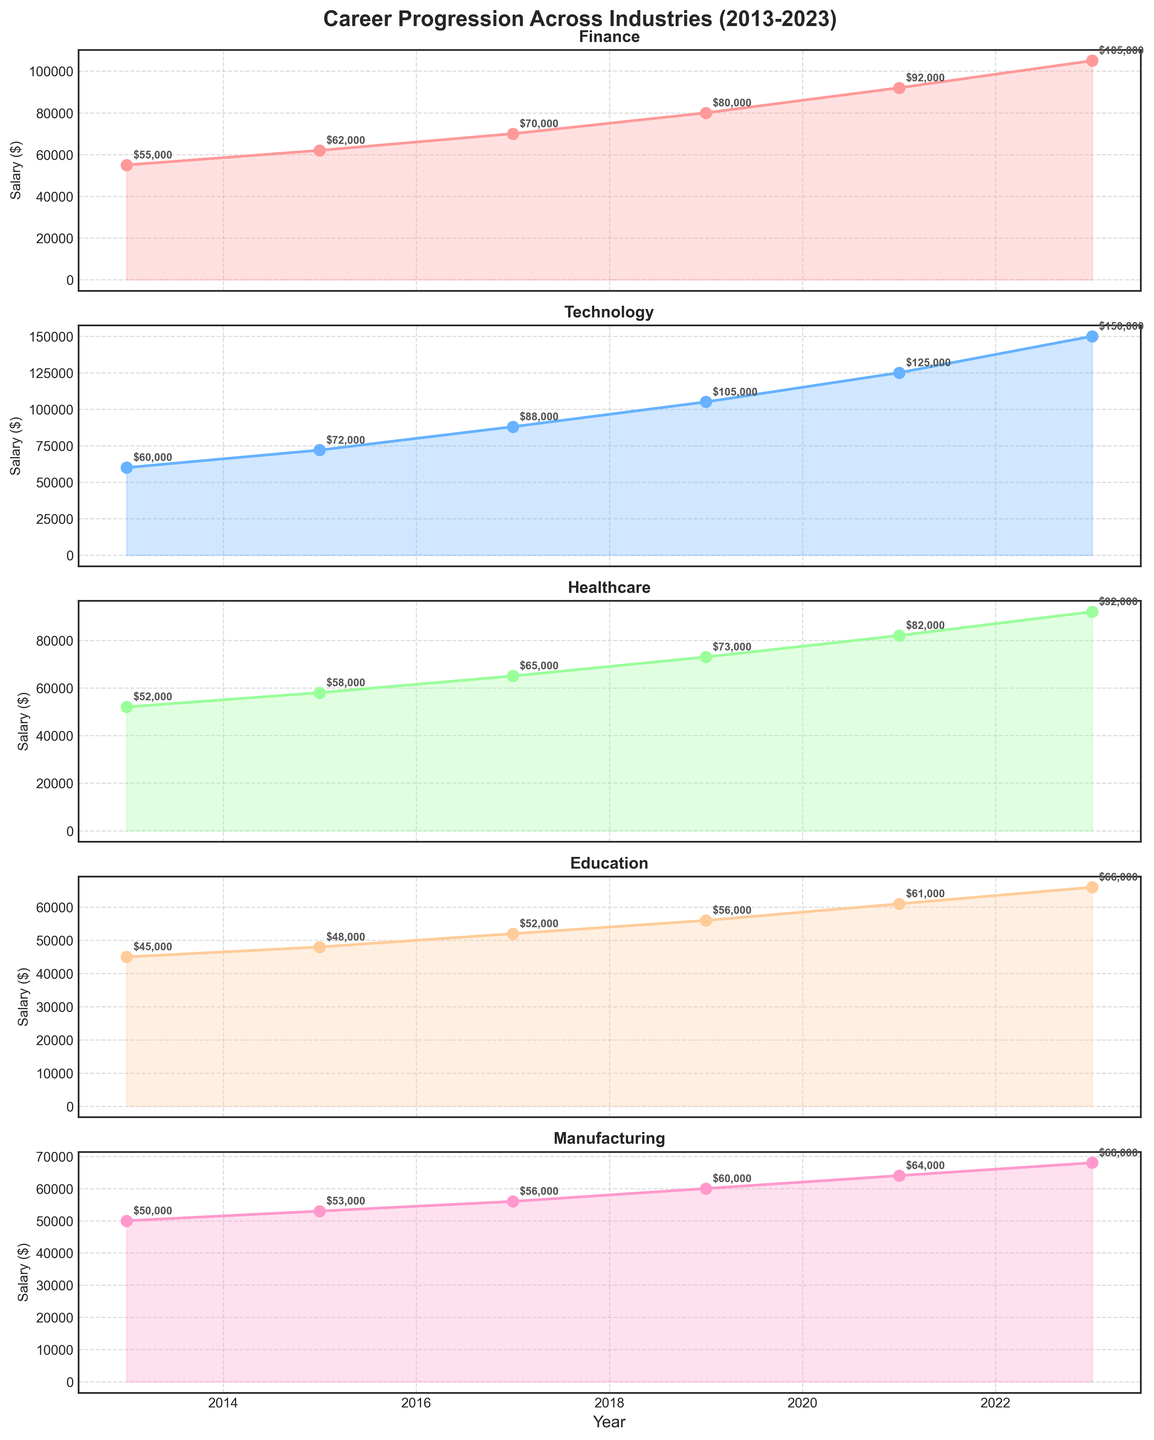What is the title of the figure? The title is located at the top center of the figure and reads "Career Progression Across Industries (2013-2023)"
Answer: Career Progression Across Industries (2013-2023) Which industry had the highest salary in 2023? Look at the salary data for all industries in 2023, and compare them visually. The Technology industry stands out with the highest salary.
Answer: Technology How much did the manufacturing industry salary increase from 2013 to 2023? Extract the salary data for the Manufacturing industry in 2013 and 2023. Subtract the 2013 value from the 2023 value: 68,000 - 50,000 = 18,000
Answer: 18,000 Which industry experienced the most rapid salary growth between 2013 and 2023? Calculate the salary difference between 2023 and 2013 for each industry. Compare those values to determine the highest: Technology (150,000 - 60,000 = 90,000).
Answer: Technology What was the average salary in the Healthcare industry over the 10-year period? Add the salaries for the Healthcare industry from 2013, 2015, 2017, 2019, 2021, and 2023 and divide by the number of years: (52,000 + 58,000 + 65,000 + 73,000 + 82,000 + 92,000)/6 = 70,333.33
Answer: 70,333.33 Which years show a noticeable spike in salaries across all industries? Look at each subplot and identify the years where most lines have a significant upward trajectory. The years 2017, 2019, and 2021 show noticeable spikes.
Answer: 2017, 2019, 2021 Comparing the finance and education industries, in which year did their salary difference peak? Calculate the salary difference between Finance and Education for each year and find where the difference is largest: 2023, (105,000 - 66,000 = 39,000).
Answer: 2023 Which industry had the lowest salary in 2015? Look at the 2015 salary data for all industries and identify the lowest value. Education has the lowest salary at 48,000.
Answer: Education 